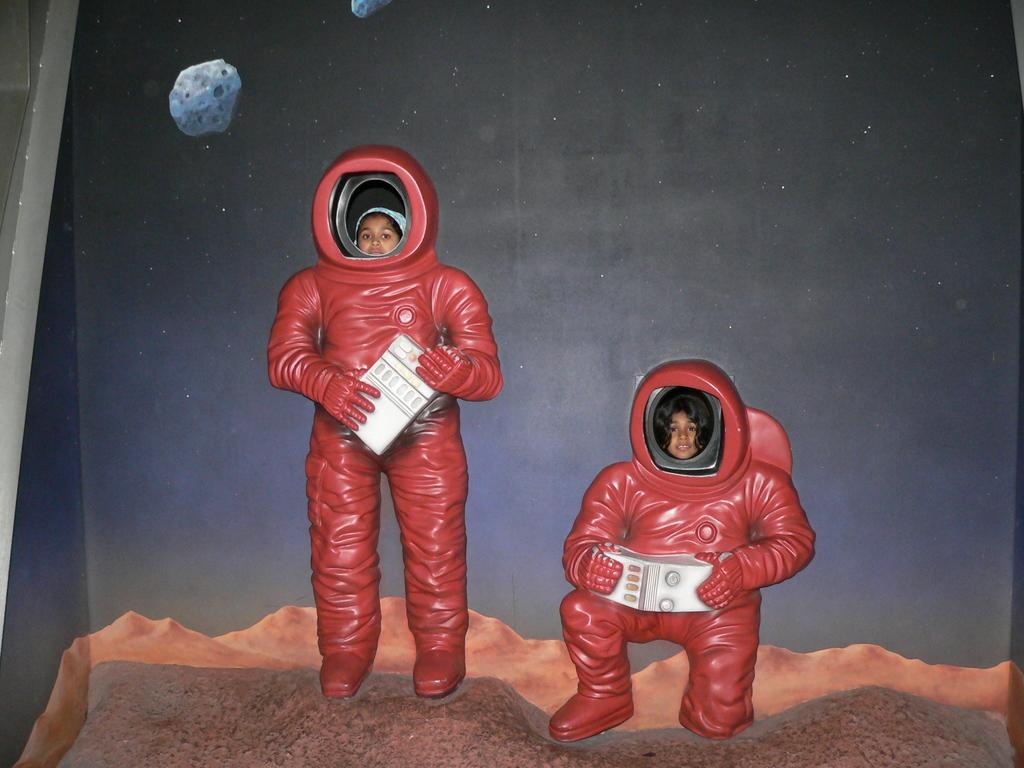What is in the foreground of the picture? There is a poster in the foreground of the picture. What is depicted on the poster? The poster features astronauts. What are the kids doing in relation to the poster? Kids are standing in the faces of the astronauts on the poster. What type of bun can be seen on the head of the astronaut in the image? There is no bun present on the head of the astronaut in the image, as the astronauts are depicted in their space suits. What is the cork used for in the image? There is no cork present in the image. 